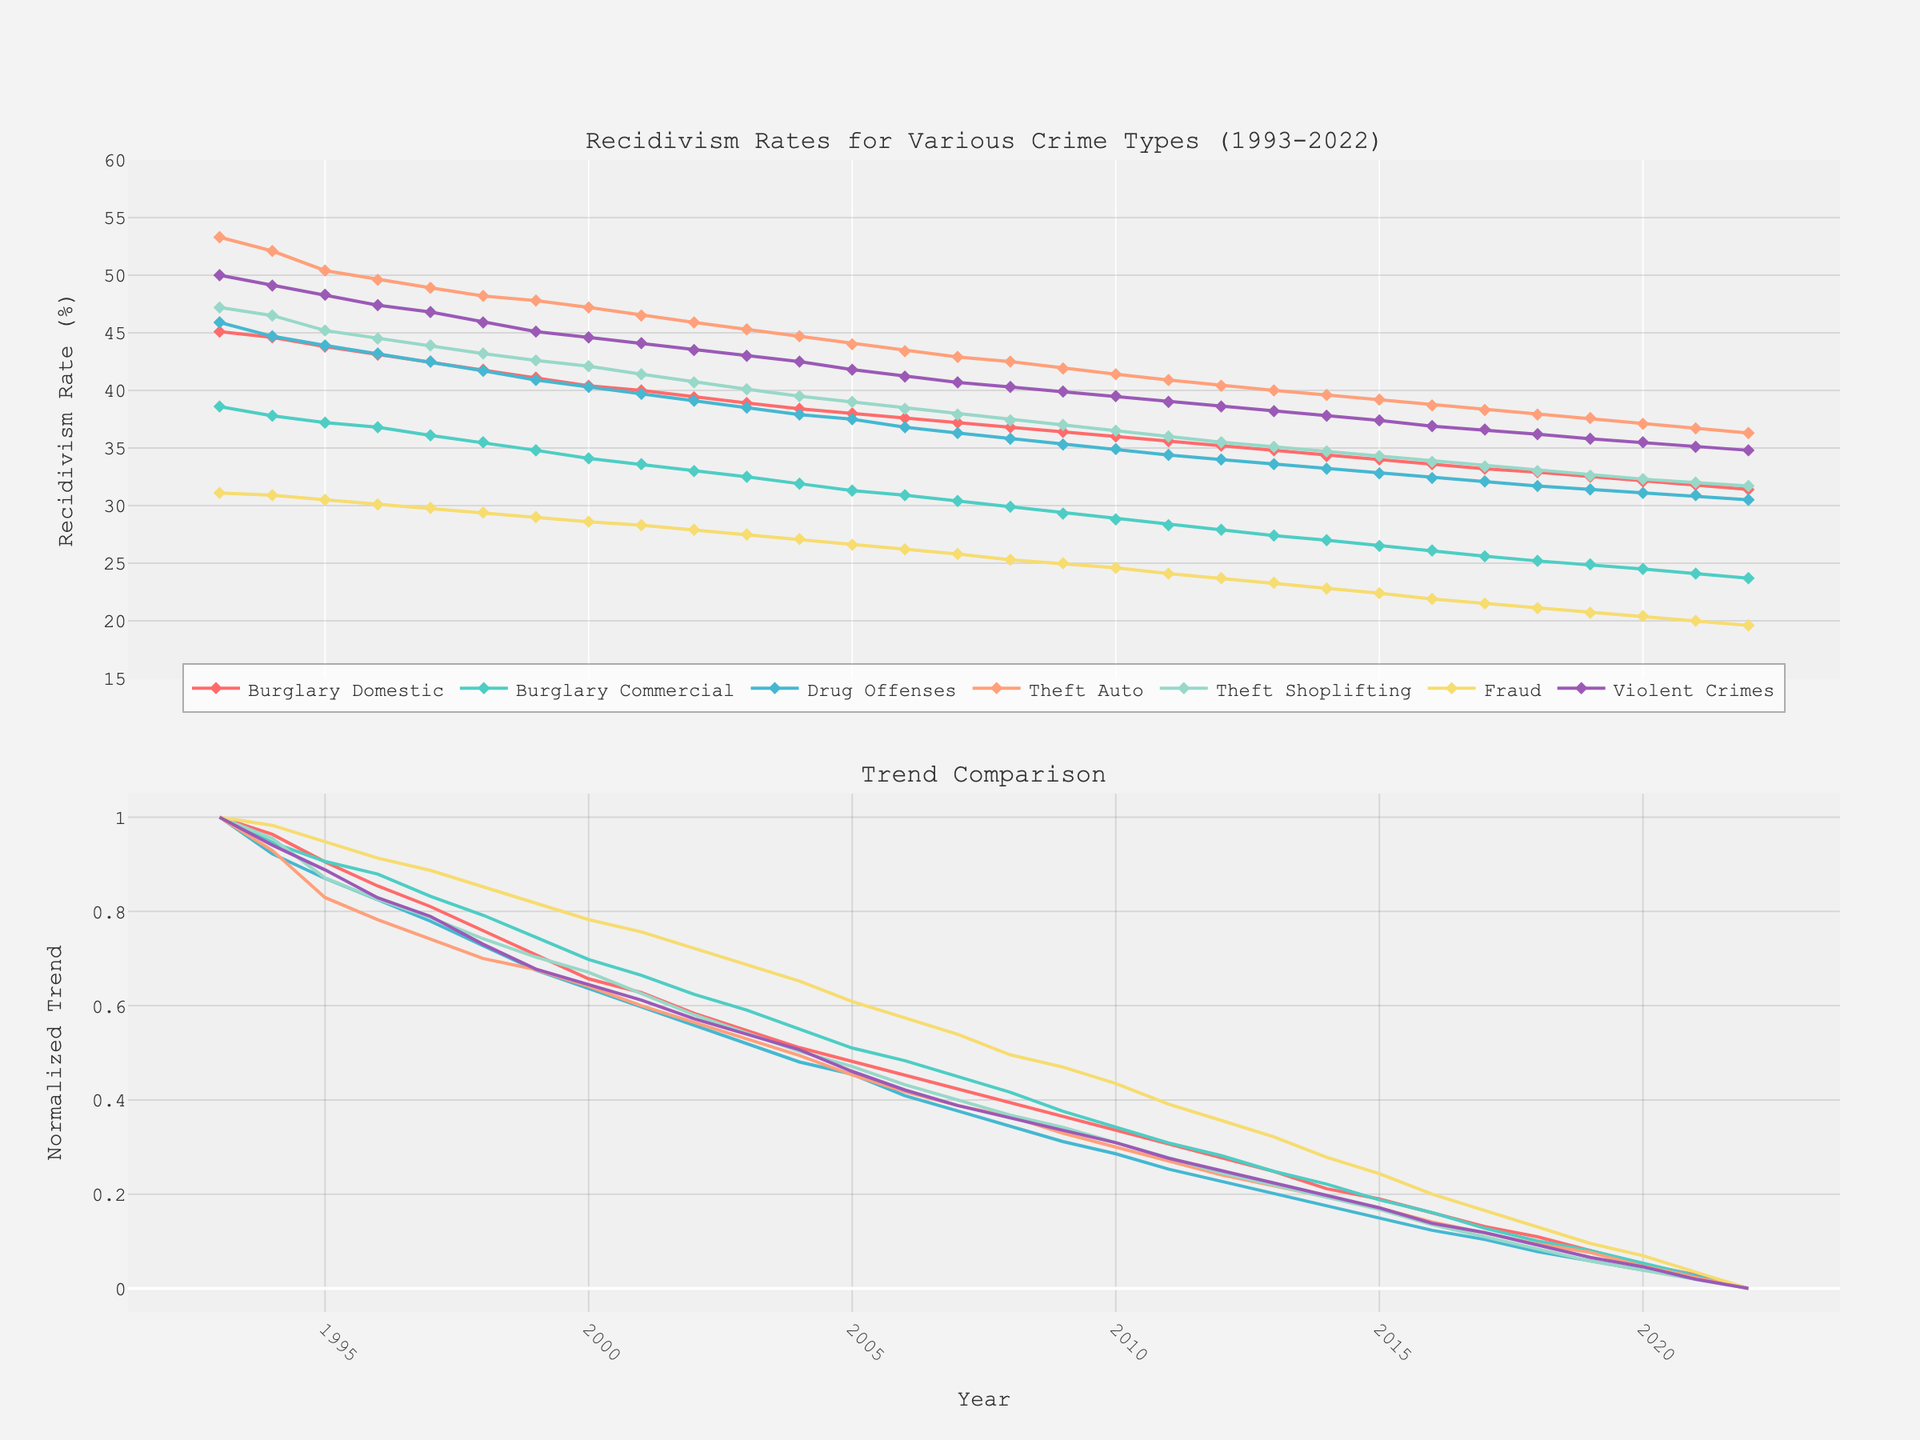What is the general trend of recidivism rates for Drug Offenses from 1993 to 2022? The plot shows that the recidivism rate for Drug Offenses has decreased overall. The line representing Drug Offenses recidivism starts at 45.9% in 1993 and ends at approximately 30.5% in 2022, indicating a downward trend.
Answer: Downward Which crime type had the highest recidivism rate in 2022? The figure indicates that Theft_Auto has the highest recidivism rate in 2022. The plot for Theft_Auto peaks higher than the other crime types at around 36.3%.
Answer: Theft_Auto How many crime types are presented in the figure? There are seven different lines, each representing a unique crime type. These include Burglary_Domestic, Burglary_Commercial, Drug_Offenses, Theft_Auto, Theft_Shoplifting, Fraud, and Violent_Crimes.
Answer: 7 Which crime type shows the most significant decline in recidivism rates over the past 30 years? By comparing the start and end points of each line, Violent_Crimes shows a significant drop. It starts at 50.0% in 1993 and drops to around 34.8% in 2022. This indicates a major decline.
Answer: Violent_Crimes What is the general trend of recidivism rates for Fraud from 1993 to 2022? The line representing Fraud recidivism starts at 31.1% in 1993 and ends at around 19.6% in 2022. This indicates a declining trend over the period.
Answer: Downward Which crime type had a higher recidivism rate in 2000, Burglary_Domestic or Burglary_Commercial? By comparing the points on the graph for the year 2000, Burglary_Domestic shows a rate of around 40.4%, while Burglary_Commercial is approximately 34.1%. Therefore, Burglary_Domestic had a higher rate.
Answer: Burglary_Domestic Between which years did Drug_Offenses see the most significant drop in recidivism rate? Drug_Offenses sees a notable decline from 2012 (34.0%) to 2013 (33.6%), although the overall trend is steadily downward. This is estimated through year-on-year drops represented on the figure, with smaller subsequent changes compared to this period.
Answer: 2012 to 2013 What is the main observation made about the recidivism rates over the past 30 years? The annotation on the figure highlights that there is a general decline in recidivism rates across all crime types over the last three decades.
Answer: General decline What is the normalized trend for Theft_Shoplifting compared to other types of crimes? In the normalized trend subplot, Theft_Shoplifting appears to follow a similar declining pattern compared to other crimes, but maintains a higher rate relative to some other types. This can be estimated by looking at its comparison line in the normalized trend subplot.
Answer: Similar declining pattern Which crime type's recidivism rate was closest to 40% in the mid-2000s? By examining the rates in the mid-2000s around 2005 to 2006, Theft_Auto's recidivism rate is closest to 40%. It stands just above 43.0% and trends slightly downward during those years.
Answer: Theft_Auto 